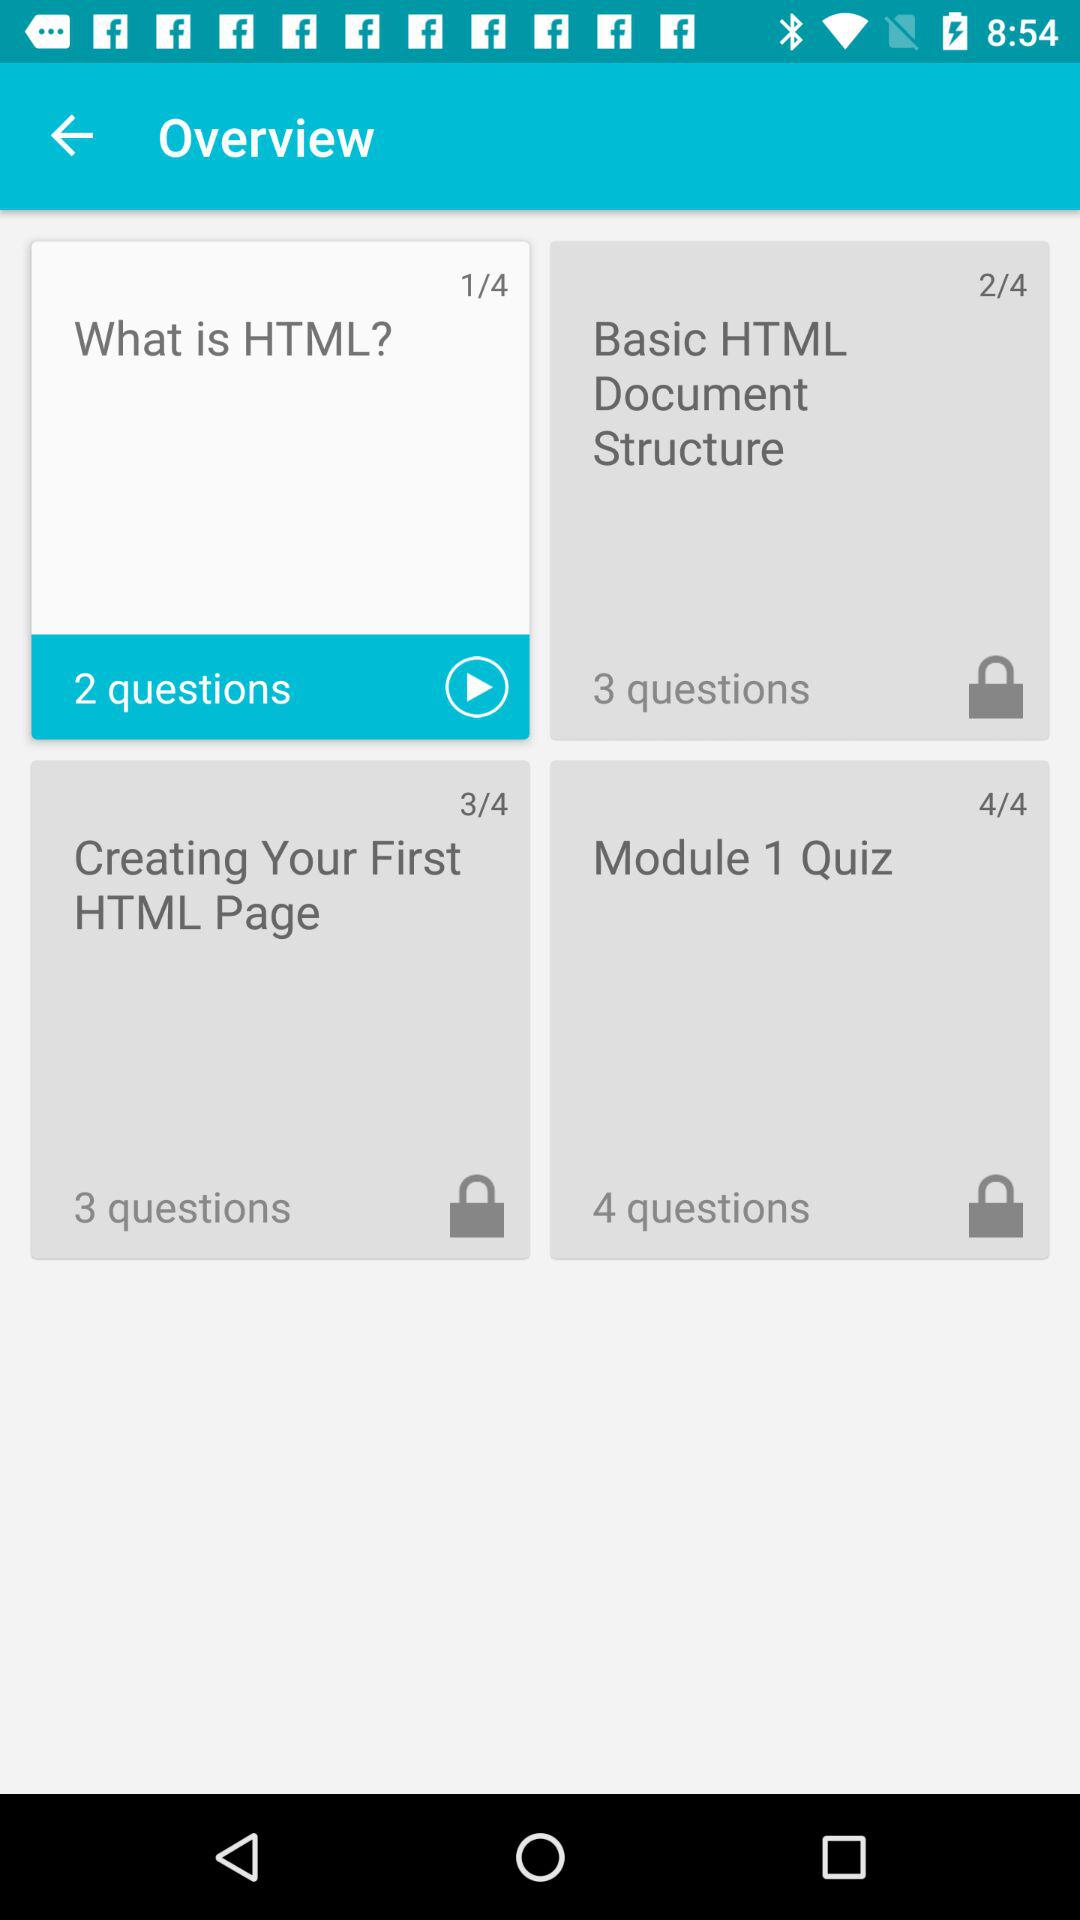What is the name of the topic that has 4 questions? The topic having 4 questions is "Module 1 Quiz". 